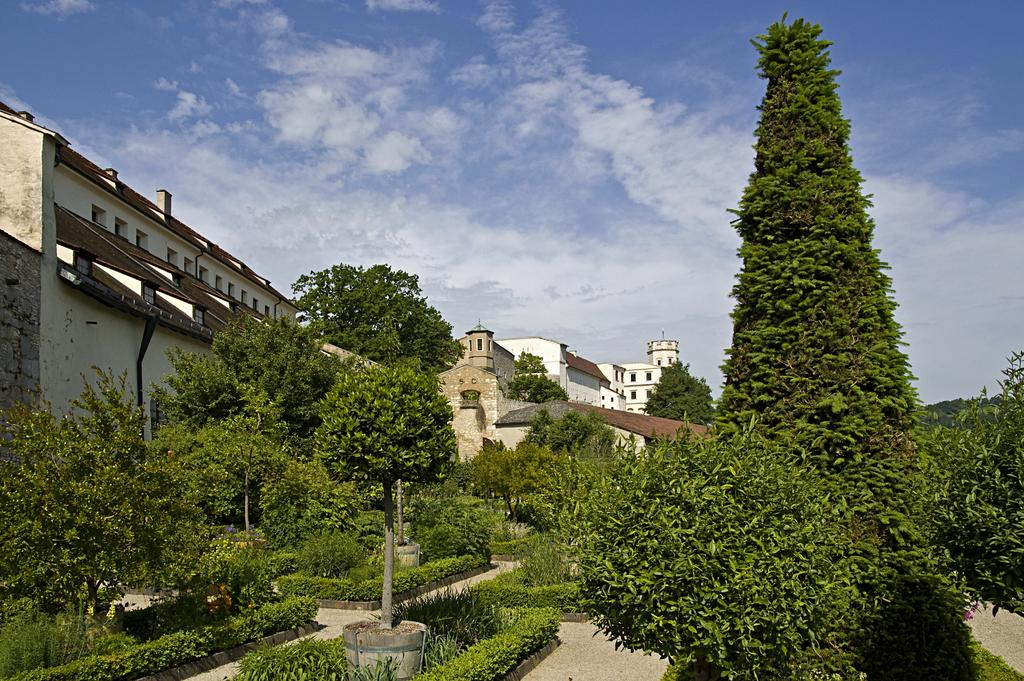What type of natural elements can be seen in the image? There are trees in the image. What type of man-made structures are present in the image? There are buildings in the image. What is visible in the sky at the top of the image? There are clouds in the sky at the top of the image. What type of fruit is hanging from the trees in the image? There is no fruit visible on the trees in the image. Can you see a zipper on any of the buildings in the image? There is no zipper present on any of the buildings in the image. 